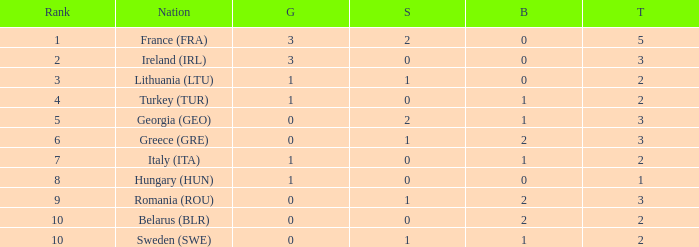What's the rank of Turkey (TUR) with a total more than 2? 0.0. 